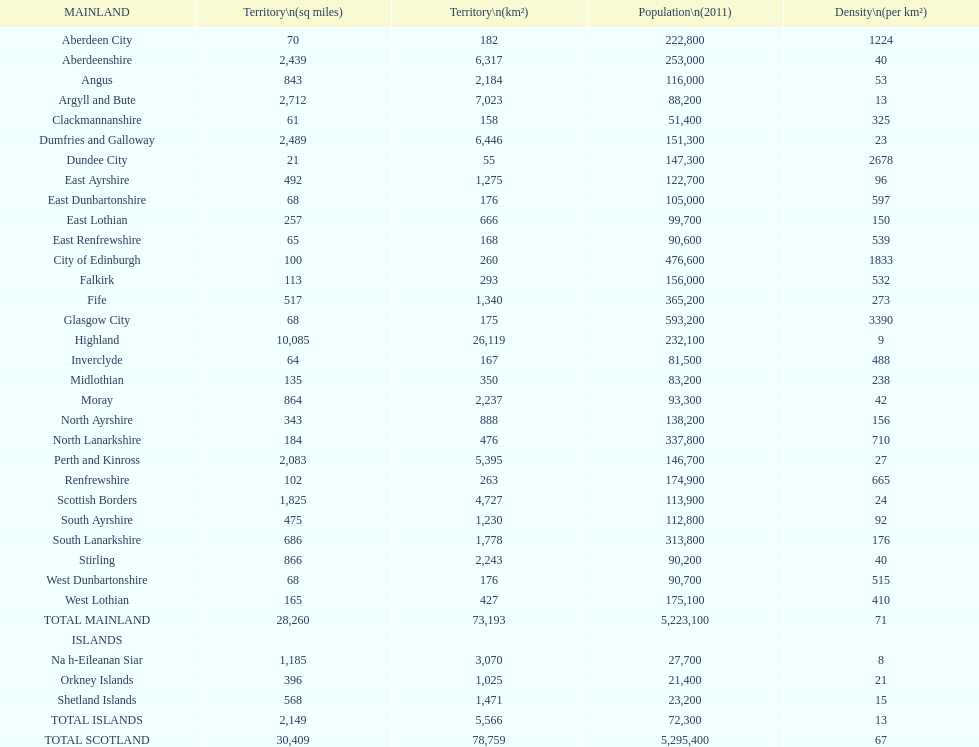If you were to arrange the locations from the smallest to largest area, which one would be first on the list? Dundee City. 